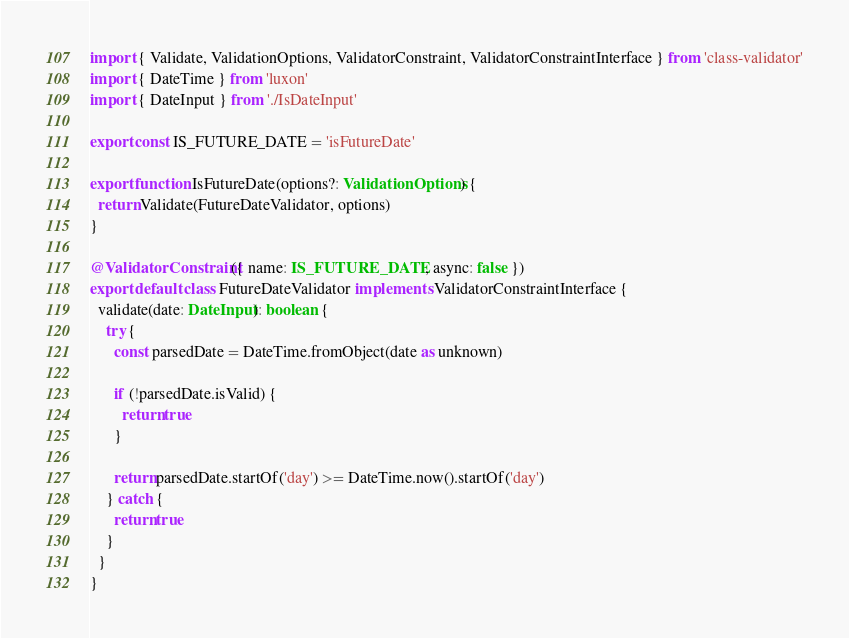Convert code to text. <code><loc_0><loc_0><loc_500><loc_500><_TypeScript_>import { Validate, ValidationOptions, ValidatorConstraint, ValidatorConstraintInterface } from 'class-validator'
import { DateTime } from 'luxon'
import { DateInput } from './IsDateInput'

export const IS_FUTURE_DATE = 'isFutureDate'

export function IsFutureDate(options?: ValidationOptions) {
  return Validate(FutureDateValidator, options)
}

@ValidatorConstraint({ name: IS_FUTURE_DATE, async: false })
export default class FutureDateValidator implements ValidatorConstraintInterface {
  validate(date: DateInput): boolean {
    try {
      const parsedDate = DateTime.fromObject(date as unknown)

      if (!parsedDate.isValid) {
        return true
      }

      return parsedDate.startOf('day') >= DateTime.now().startOf('day')
    } catch {
      return true
    }
  }
}
</code> 